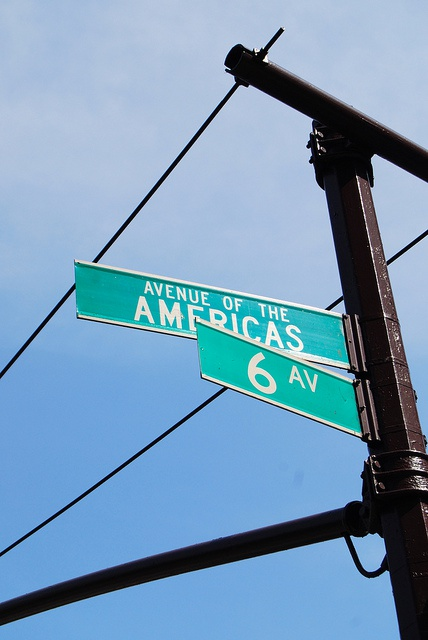Describe the objects in this image and their specific colors. I can see various objects in this image with different colors. 